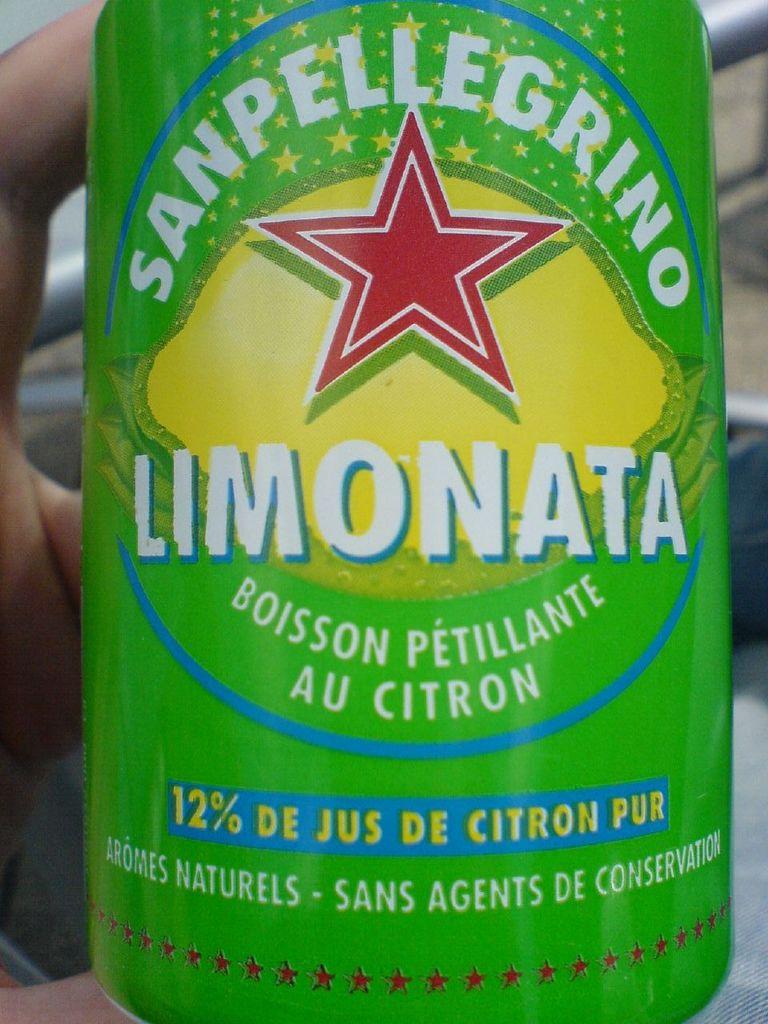What percent is listed?
Make the answer very short. 12%. What is the brand here?
Offer a very short reply. Sanpellegrino. 